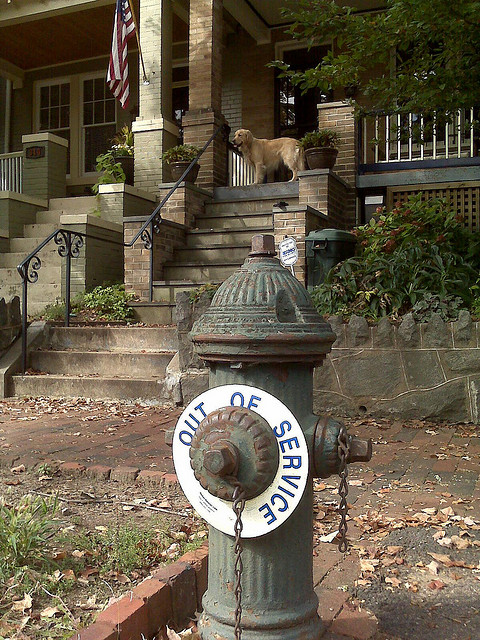Identify and read out the text in this image. OUT OF SERVICE 